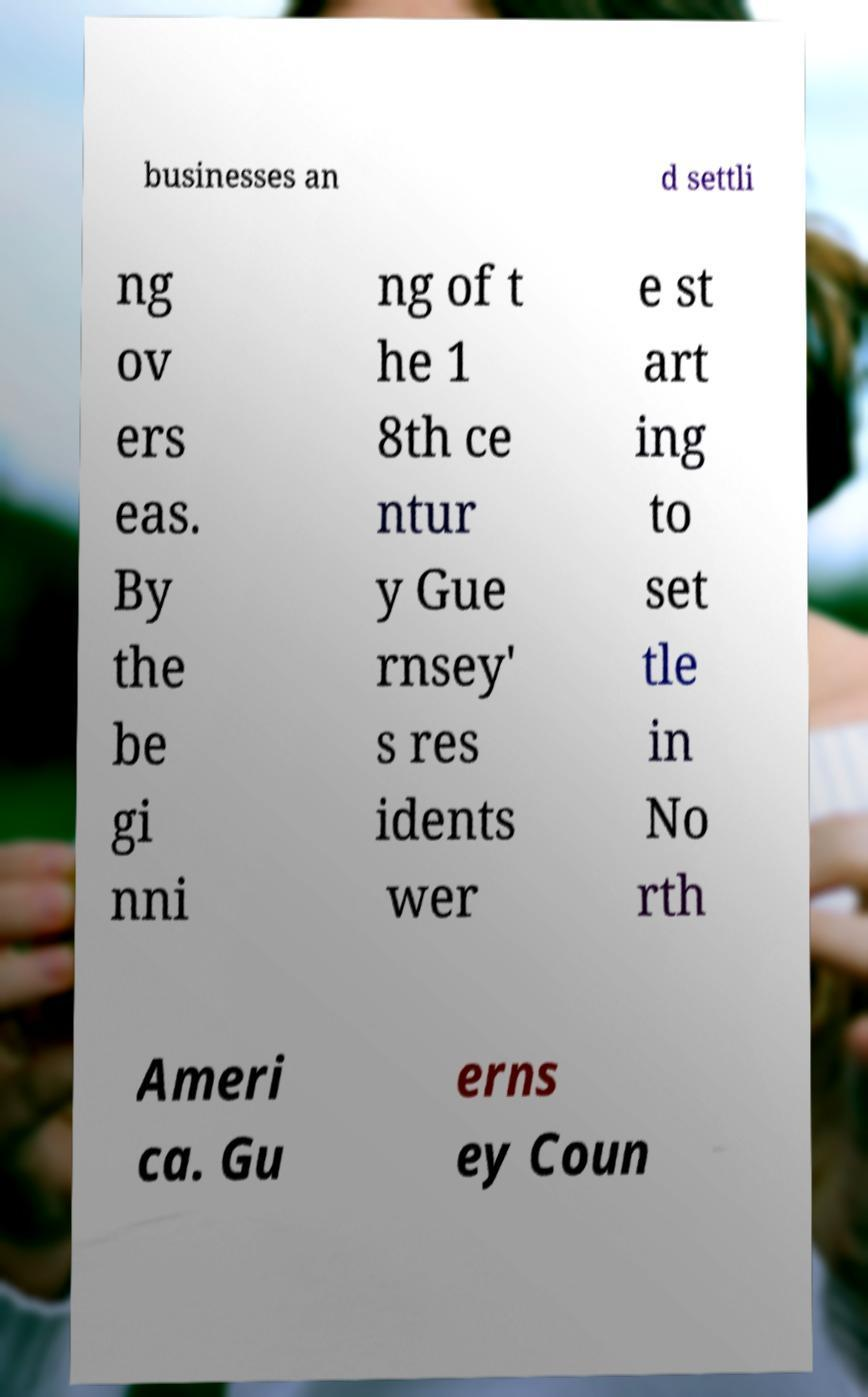Can you accurately transcribe the text from the provided image for me? businesses an d settli ng ov ers eas. By the be gi nni ng of t he 1 8th ce ntur y Gue rnsey' s res idents wer e st art ing to set tle in No rth Ameri ca. Gu erns ey Coun 